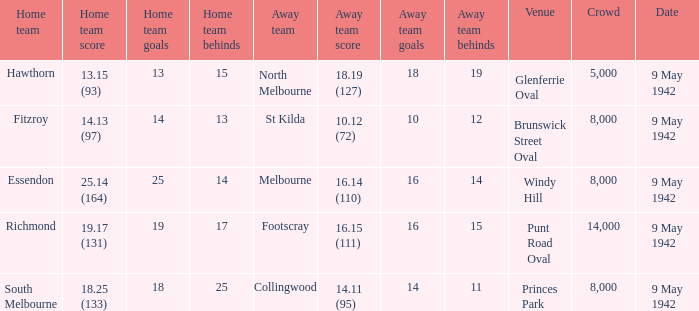How many people attended the game where Footscray was away? 14000.0. 